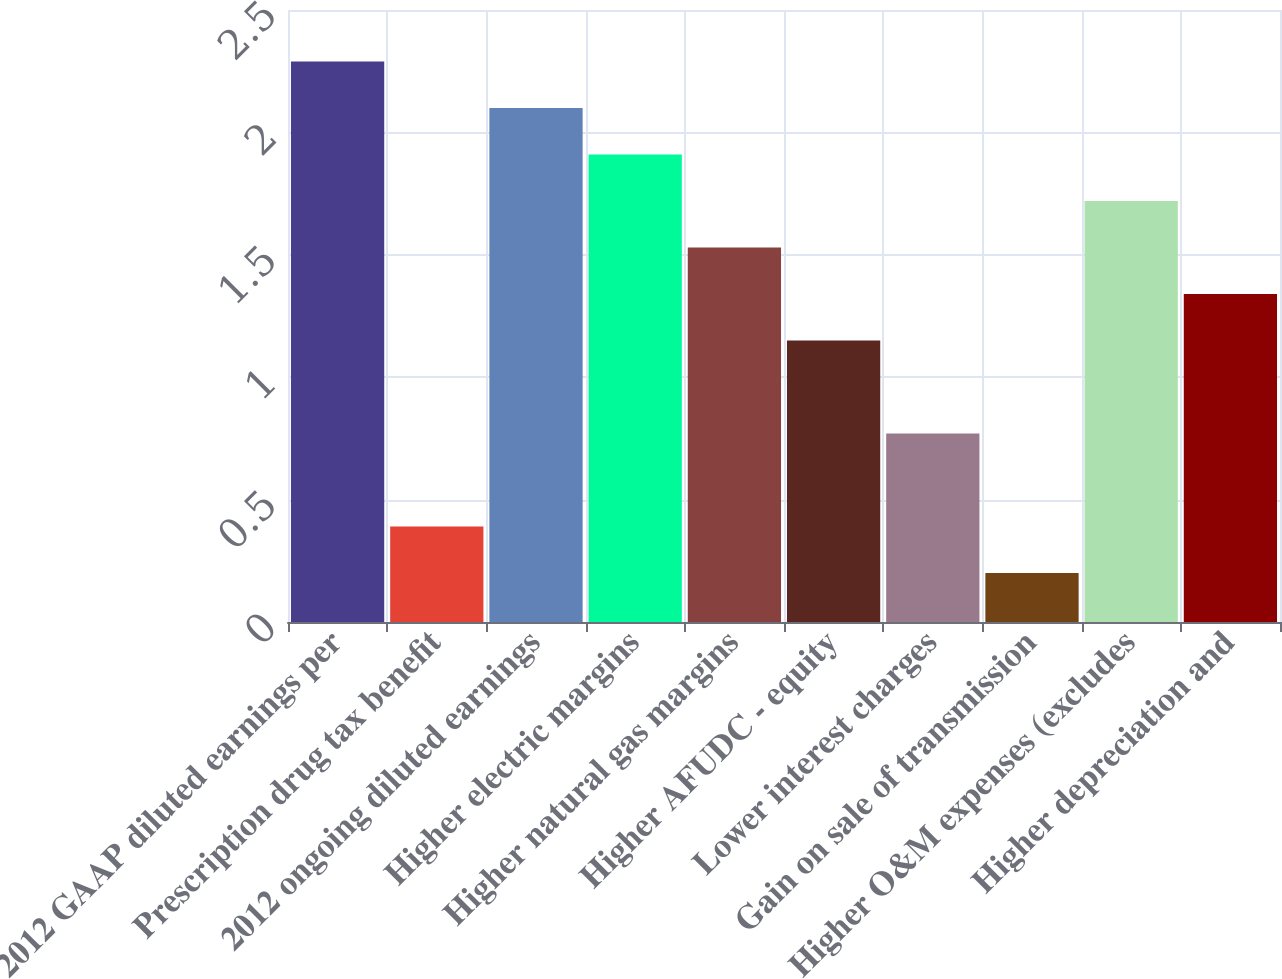Convert chart. <chart><loc_0><loc_0><loc_500><loc_500><bar_chart><fcel>2012 GAAP diluted earnings per<fcel>Prescription drug tax benefit<fcel>2012 ongoing diluted earnings<fcel>Higher electric margins<fcel>Higher natural gas margins<fcel>Higher AFUDC - equity<fcel>Lower interest charges<fcel>Gain on sale of transmission<fcel>Higher O&M expenses (excludes<fcel>Higher depreciation and<nl><fcel>2.29<fcel>0.39<fcel>2.1<fcel>1.91<fcel>1.53<fcel>1.15<fcel>0.77<fcel>0.2<fcel>1.72<fcel>1.34<nl></chart> 